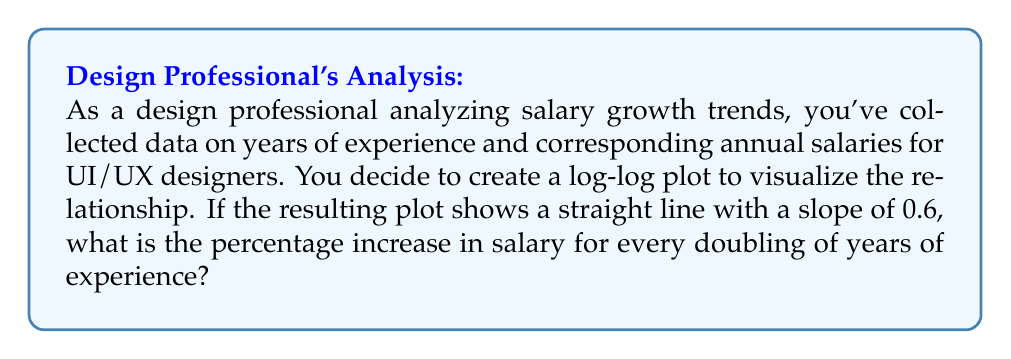What is the answer to this math problem? Let's approach this step-by-step:

1) In a log-log plot, if the relationship between two variables $x$ and $y$ is of the form:

   $$y = ax^b$$

   where $a$ and $b$ are constants, the plot will show a straight line with slope $b$.

2) In our case, $x$ represents years of experience, $y$ represents salary, and the slope $b = 0.6$.

3) To find the salary increase when experience doubles, we need to compare $y_2$ (new salary) to $y_1$ (original salary):

   $$\frac{y_2}{y_1} = \frac{a(2x)^{0.6}}{ax^{0.6}} = \frac{2^{0.6}x^{0.6}}{x^{0.6}} = 2^{0.6}$$

4) Calculate $2^{0.6}$:
   
   $$2^{0.6} \approx 1.5157$$

5) To express this as a percentage increase:

   $$(1.5157 - 1) \times 100\% \approx 51.57\%$$

Therefore, for every doubling of years of experience, the salary increases by approximately 51.57%.
Answer: The salary increases by approximately 51.57% for every doubling of years of experience. 